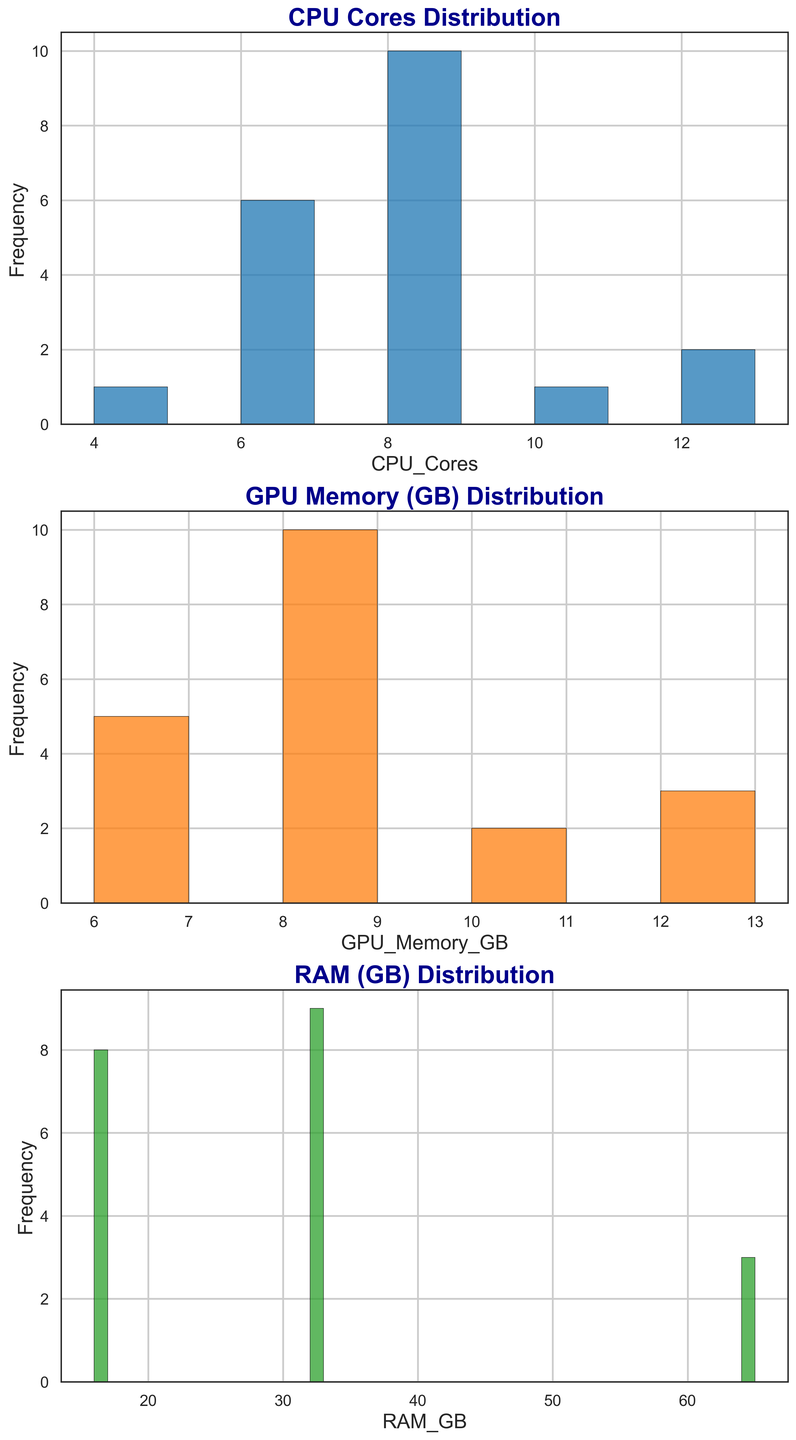Which CPU core count is the most common among high-performance gaming rigs? To answer this, we'll look for the tallest bar in the CPU Cores Distribution histogram. The tallest bar is at 8 CPU cores, indicating it is the most common.
Answer: 8 Which has more instances: gaming rigs with 6 CPU cores or gaming rigs with 12 CPU cores? Compare the height of the bars for 6 CPU cores and 12 CPU cores in the CPU Cores Distribution histogram. The bar for 6 CPU cores is taller than the bar for 12 CPU cores.
Answer: 6 CPU cores What's the range of GPU memory values observed among the gaming rigs? Identify the minimum and maximum values in the GPU Memory (GB) Distribution histogram. The values range from 6 GB to 12 GB.
Answer: 6 GB to 12 GB Does any category in RAM distribution have more instances than the most common CPU core count? Check the highest bar in the RAM (GB) Distribution histogram and compare its height to the 8 CPU cores bar in the CPU Cores Distribution histogram. None of the RAM bars surpass the height of the 8 CPU cores bar.
Answer: No How many gaming rigs have at least 32 GB of RAM? Sum the frequencies of the bars at 32 GB and 64 GB in the RAM (GB) Distribution histogram. There are 10 rigs with 32 GB and 3 rigs with 64 GB, totaling 13 rigs.
Answer: 13 Which is more common: GPUs with 8 GB of memory or GPUs with 10 GB of memory? Compare the heights of the 8 GB and 10 GB GPU memory bars in the GPU Memory (GB) Distribution histogram. The 8 GB bar is taller.
Answer: 8 GB Among RAM (GB) distributions, what's the difference in frequency between the most and least common values? Identify the highest bar and the lowest bar in the RAM (GB) Distribution histogram. The 32 GB (10) is the highest and 64 GB (3) is the lowest. The difference is 10 - 3 = 7.
Answer: 7 If you combine the instances of CPUs with 4 and 6 cores, do they surpass the instances of 8-core CPUs? Add the frequencies of the bars for 4 and 6 cores in the CPU Cores Distribution histogram. There are 1 + 6 = 7 rigs. The instances of the 8-core CPUs are 9. Since 7 < 9, they do not surpass them.
Answer: No Which GPU memory value has the least frequency? Identify the shortest bar in the GPU Memory (GB) Distribution histogram. The shortest is for 12 GB.
Answer: 12 GB 